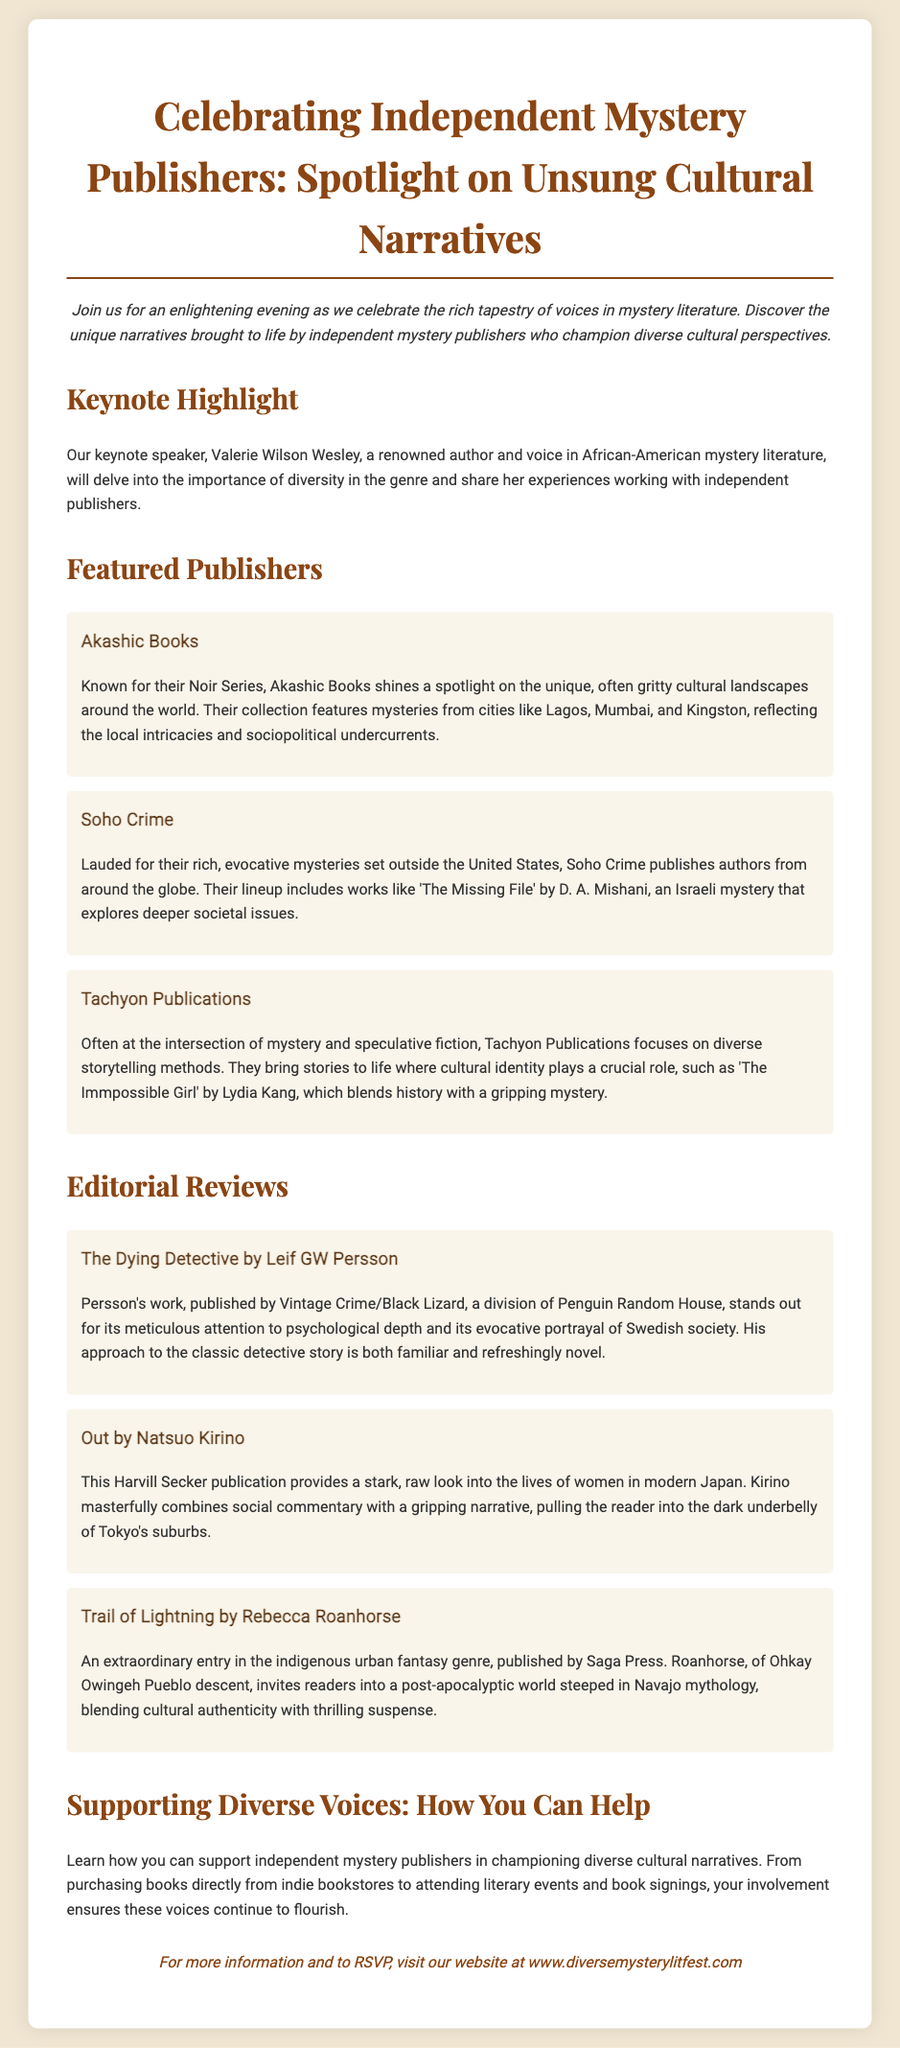What is the title of the event? The title is explicitly stated at the top of the document.
Answer: Celebrating Independent Mystery Publishers: Spotlight on Unsung Cultural Narratives Who is the keynote speaker? The document specifies who will deliver the keynote address.
Answer: Valerie Wilson Wesley Which publisher is known for their Noir Series? This information is found in the section discussing featured publishers.
Answer: Akashic Books What does Tachyon Publications focus on? The description of Tachyon Publications outlines their thematic focus.
Answer: Diverse storytelling methods Which book is reviewed that is authored by Natsuo Kirino? The review section names this book specifically.
Answer: Out What type of insights does Valerie Wilson Wesley discuss? The text explains the content of the keynote speech regarding literary diversity.
Answer: Importance of diversity in the genre What genre does "Trail of Lightning" by Rebecca Roanhorse belong to? The description of the book provides its genre classification.
Answer: Indigenous urban fantasy What is encouraged to support independent mystery publishers? The document suggests a specific type of action for support at the end.
Answer: Purchasing books directly from indie bookstores 